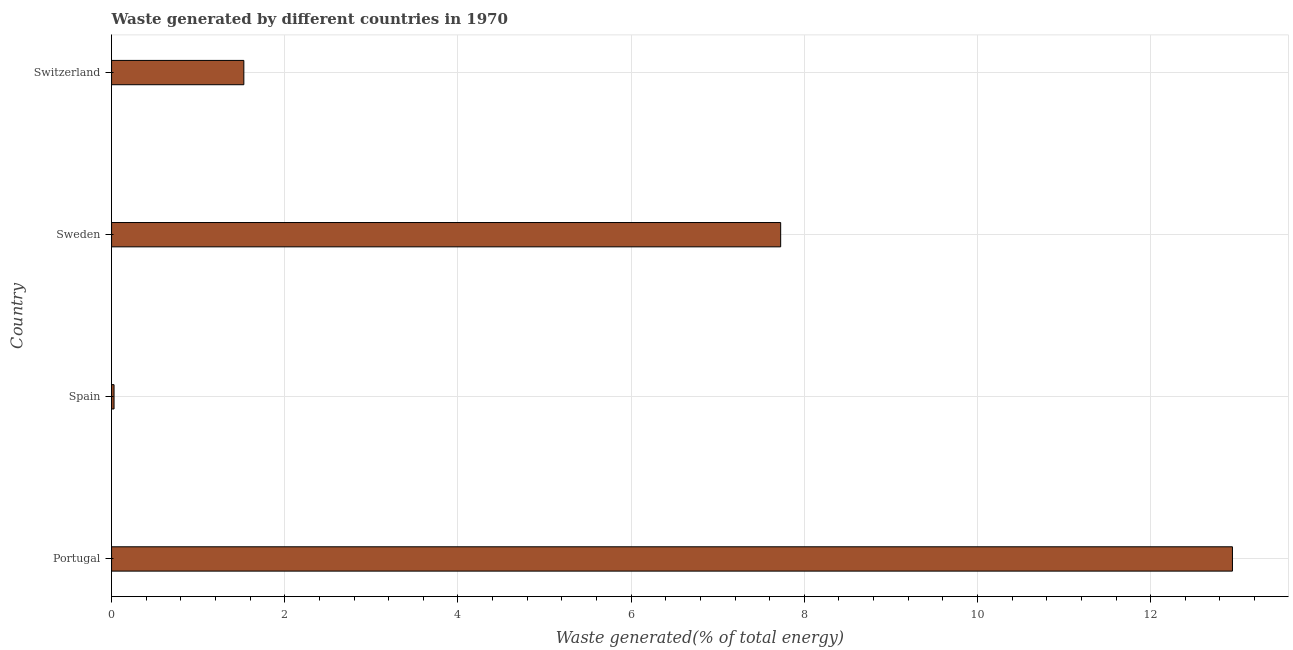Does the graph contain any zero values?
Keep it short and to the point. No. Does the graph contain grids?
Provide a succinct answer. Yes. What is the title of the graph?
Provide a short and direct response. Waste generated by different countries in 1970. What is the label or title of the X-axis?
Provide a short and direct response. Waste generated(% of total energy). What is the label or title of the Y-axis?
Your answer should be very brief. Country. What is the amount of waste generated in Switzerland?
Provide a short and direct response. 1.53. Across all countries, what is the maximum amount of waste generated?
Keep it short and to the point. 12.94. Across all countries, what is the minimum amount of waste generated?
Give a very brief answer. 0.03. In which country was the amount of waste generated minimum?
Ensure brevity in your answer.  Spain. What is the sum of the amount of waste generated?
Your answer should be compact. 22.23. What is the difference between the amount of waste generated in Spain and Switzerland?
Your answer should be compact. -1.5. What is the average amount of waste generated per country?
Keep it short and to the point. 5.56. What is the median amount of waste generated?
Your answer should be very brief. 4.63. In how many countries, is the amount of waste generated greater than 3.2 %?
Give a very brief answer. 2. What is the ratio of the amount of waste generated in Sweden to that in Switzerland?
Offer a very short reply. 5.06. Is the amount of waste generated in Portugal less than that in Switzerland?
Your answer should be very brief. No. Is the difference between the amount of waste generated in Portugal and Spain greater than the difference between any two countries?
Provide a succinct answer. Yes. What is the difference between the highest and the second highest amount of waste generated?
Offer a very short reply. 5.22. What is the difference between the highest and the lowest amount of waste generated?
Offer a terse response. 12.92. In how many countries, is the amount of waste generated greater than the average amount of waste generated taken over all countries?
Make the answer very short. 2. How many countries are there in the graph?
Ensure brevity in your answer.  4. What is the difference between two consecutive major ticks on the X-axis?
Provide a succinct answer. 2. What is the Waste generated(% of total energy) of Portugal?
Offer a terse response. 12.94. What is the Waste generated(% of total energy) of Spain?
Keep it short and to the point. 0.03. What is the Waste generated(% of total energy) in Sweden?
Your answer should be compact. 7.73. What is the Waste generated(% of total energy) of Switzerland?
Provide a succinct answer. 1.53. What is the difference between the Waste generated(% of total energy) in Portugal and Spain?
Make the answer very short. 12.92. What is the difference between the Waste generated(% of total energy) in Portugal and Sweden?
Keep it short and to the point. 5.22. What is the difference between the Waste generated(% of total energy) in Portugal and Switzerland?
Provide a succinct answer. 11.42. What is the difference between the Waste generated(% of total energy) in Spain and Sweden?
Ensure brevity in your answer.  -7.7. What is the difference between the Waste generated(% of total energy) in Spain and Switzerland?
Make the answer very short. -1.5. What is the difference between the Waste generated(% of total energy) in Sweden and Switzerland?
Ensure brevity in your answer.  6.2. What is the ratio of the Waste generated(% of total energy) in Portugal to that in Spain?
Offer a very short reply. 451.48. What is the ratio of the Waste generated(% of total energy) in Portugal to that in Sweden?
Keep it short and to the point. 1.68. What is the ratio of the Waste generated(% of total energy) in Portugal to that in Switzerland?
Offer a very short reply. 8.47. What is the ratio of the Waste generated(% of total energy) in Spain to that in Sweden?
Offer a terse response. 0. What is the ratio of the Waste generated(% of total energy) in Spain to that in Switzerland?
Keep it short and to the point. 0.02. What is the ratio of the Waste generated(% of total energy) in Sweden to that in Switzerland?
Keep it short and to the point. 5.06. 